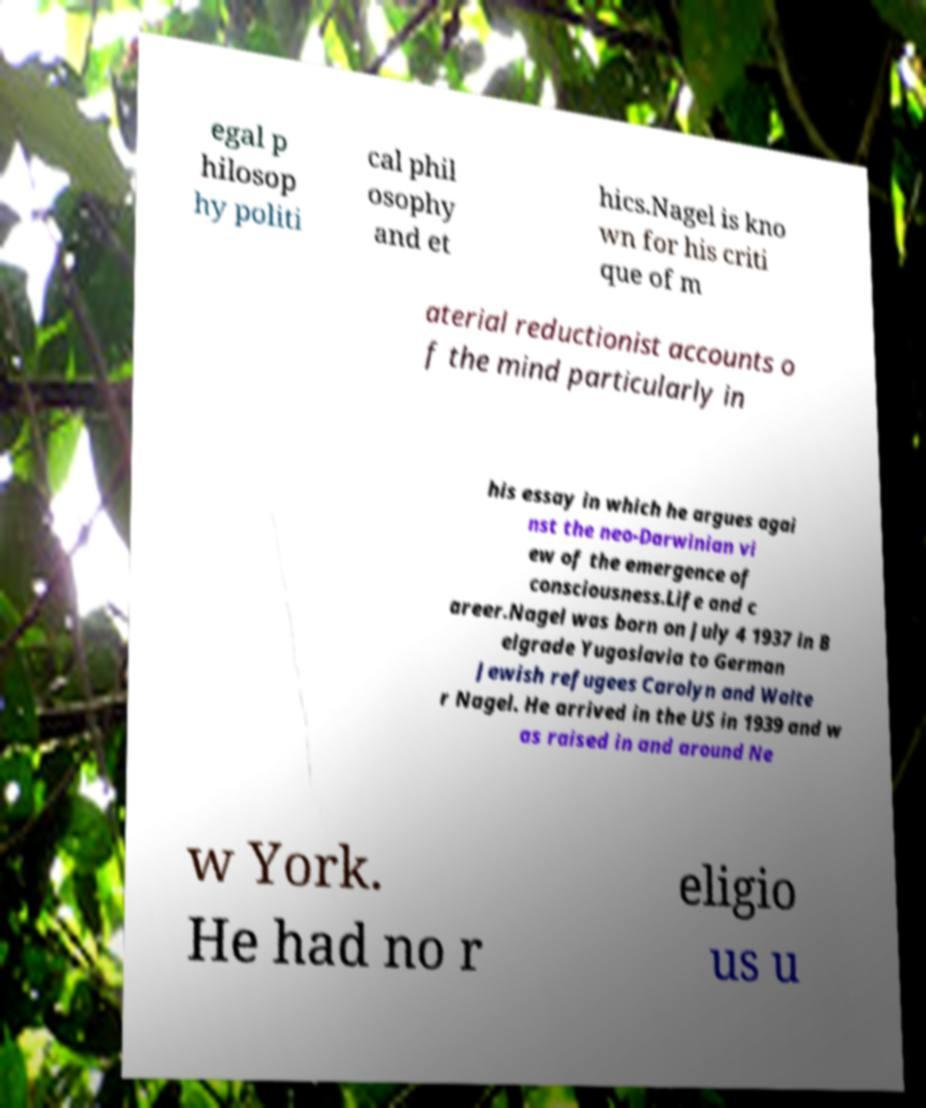Could you extract and type out the text from this image? egal p hilosop hy politi cal phil osophy and et hics.Nagel is kno wn for his criti que of m aterial reductionist accounts o f the mind particularly in his essay in which he argues agai nst the neo-Darwinian vi ew of the emergence of consciousness.Life and c areer.Nagel was born on July 4 1937 in B elgrade Yugoslavia to German Jewish refugees Carolyn and Walte r Nagel. He arrived in the US in 1939 and w as raised in and around Ne w York. He had no r eligio us u 